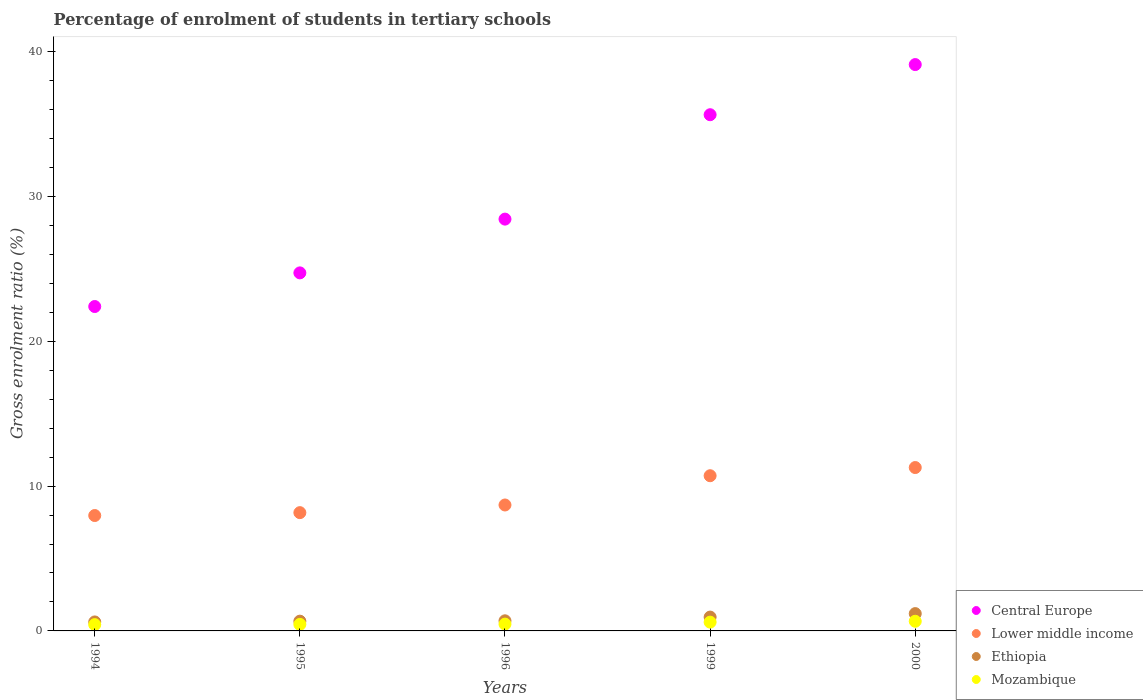What is the percentage of students enrolled in tertiary schools in Lower middle income in 1994?
Ensure brevity in your answer.  7.97. Across all years, what is the maximum percentage of students enrolled in tertiary schools in Lower middle income?
Give a very brief answer. 11.28. Across all years, what is the minimum percentage of students enrolled in tertiary schools in Lower middle income?
Provide a short and direct response. 7.97. In which year was the percentage of students enrolled in tertiary schools in Lower middle income maximum?
Make the answer very short. 2000. In which year was the percentage of students enrolled in tertiary schools in Ethiopia minimum?
Provide a succinct answer. 1994. What is the total percentage of students enrolled in tertiary schools in Mozambique in the graph?
Your answer should be compact. 2.63. What is the difference between the percentage of students enrolled in tertiary schools in Lower middle income in 1994 and that in 1995?
Provide a succinct answer. -0.2. What is the difference between the percentage of students enrolled in tertiary schools in Mozambique in 1994 and the percentage of students enrolled in tertiary schools in Lower middle income in 2000?
Your answer should be very brief. -10.84. What is the average percentage of students enrolled in tertiary schools in Mozambique per year?
Offer a terse response. 0.53. In the year 2000, what is the difference between the percentage of students enrolled in tertiary schools in Lower middle income and percentage of students enrolled in tertiary schools in Ethiopia?
Your answer should be very brief. 10.08. What is the ratio of the percentage of students enrolled in tertiary schools in Central Europe in 1995 to that in 1999?
Provide a short and direct response. 0.69. Is the difference between the percentage of students enrolled in tertiary schools in Lower middle income in 1995 and 2000 greater than the difference between the percentage of students enrolled in tertiary schools in Ethiopia in 1995 and 2000?
Keep it short and to the point. No. What is the difference between the highest and the second highest percentage of students enrolled in tertiary schools in Ethiopia?
Your response must be concise. 0.24. What is the difference between the highest and the lowest percentage of students enrolled in tertiary schools in Lower middle income?
Offer a terse response. 3.31. In how many years, is the percentage of students enrolled in tertiary schools in Mozambique greater than the average percentage of students enrolled in tertiary schools in Mozambique taken over all years?
Ensure brevity in your answer.  2. Is it the case that in every year, the sum of the percentage of students enrolled in tertiary schools in Ethiopia and percentage of students enrolled in tertiary schools in Mozambique  is greater than the percentage of students enrolled in tertiary schools in Lower middle income?
Your answer should be very brief. No. Does the percentage of students enrolled in tertiary schools in Mozambique monotonically increase over the years?
Provide a succinct answer. Yes. How many years are there in the graph?
Keep it short and to the point. 5. Are the values on the major ticks of Y-axis written in scientific E-notation?
Offer a very short reply. No. How many legend labels are there?
Your response must be concise. 4. How are the legend labels stacked?
Give a very brief answer. Vertical. What is the title of the graph?
Your answer should be compact. Percentage of enrolment of students in tertiary schools. Does "Hungary" appear as one of the legend labels in the graph?
Your answer should be very brief. No. What is the label or title of the Y-axis?
Give a very brief answer. Gross enrolment ratio (%). What is the Gross enrolment ratio (%) of Central Europe in 1994?
Provide a succinct answer. 22.4. What is the Gross enrolment ratio (%) of Lower middle income in 1994?
Keep it short and to the point. 7.97. What is the Gross enrolment ratio (%) in Ethiopia in 1994?
Your answer should be compact. 0.62. What is the Gross enrolment ratio (%) of Mozambique in 1994?
Your answer should be compact. 0.43. What is the Gross enrolment ratio (%) of Central Europe in 1995?
Keep it short and to the point. 24.72. What is the Gross enrolment ratio (%) in Lower middle income in 1995?
Provide a short and direct response. 8.17. What is the Gross enrolment ratio (%) in Ethiopia in 1995?
Make the answer very short. 0.67. What is the Gross enrolment ratio (%) in Mozambique in 1995?
Your answer should be very brief. 0.45. What is the Gross enrolment ratio (%) in Central Europe in 1996?
Keep it short and to the point. 28.43. What is the Gross enrolment ratio (%) in Lower middle income in 1996?
Provide a short and direct response. 8.69. What is the Gross enrolment ratio (%) of Ethiopia in 1996?
Make the answer very short. 0.7. What is the Gross enrolment ratio (%) in Mozambique in 1996?
Provide a succinct answer. 0.47. What is the Gross enrolment ratio (%) of Central Europe in 1999?
Offer a terse response. 35.64. What is the Gross enrolment ratio (%) in Lower middle income in 1999?
Keep it short and to the point. 10.71. What is the Gross enrolment ratio (%) of Ethiopia in 1999?
Offer a very short reply. 0.96. What is the Gross enrolment ratio (%) of Mozambique in 1999?
Your response must be concise. 0.61. What is the Gross enrolment ratio (%) of Central Europe in 2000?
Offer a terse response. 39.1. What is the Gross enrolment ratio (%) of Lower middle income in 2000?
Give a very brief answer. 11.28. What is the Gross enrolment ratio (%) in Ethiopia in 2000?
Offer a terse response. 1.19. What is the Gross enrolment ratio (%) of Mozambique in 2000?
Make the answer very short. 0.67. Across all years, what is the maximum Gross enrolment ratio (%) in Central Europe?
Your answer should be compact. 39.1. Across all years, what is the maximum Gross enrolment ratio (%) of Lower middle income?
Provide a succinct answer. 11.28. Across all years, what is the maximum Gross enrolment ratio (%) in Ethiopia?
Your answer should be very brief. 1.19. Across all years, what is the maximum Gross enrolment ratio (%) of Mozambique?
Give a very brief answer. 0.67. Across all years, what is the minimum Gross enrolment ratio (%) of Central Europe?
Ensure brevity in your answer.  22.4. Across all years, what is the minimum Gross enrolment ratio (%) of Lower middle income?
Keep it short and to the point. 7.97. Across all years, what is the minimum Gross enrolment ratio (%) in Ethiopia?
Your response must be concise. 0.62. Across all years, what is the minimum Gross enrolment ratio (%) in Mozambique?
Offer a terse response. 0.43. What is the total Gross enrolment ratio (%) in Central Europe in the graph?
Offer a terse response. 150.28. What is the total Gross enrolment ratio (%) of Lower middle income in the graph?
Your answer should be very brief. 46.82. What is the total Gross enrolment ratio (%) of Ethiopia in the graph?
Ensure brevity in your answer.  4.14. What is the total Gross enrolment ratio (%) in Mozambique in the graph?
Make the answer very short. 2.63. What is the difference between the Gross enrolment ratio (%) in Central Europe in 1994 and that in 1995?
Offer a terse response. -2.32. What is the difference between the Gross enrolment ratio (%) of Lower middle income in 1994 and that in 1995?
Provide a short and direct response. -0.2. What is the difference between the Gross enrolment ratio (%) in Ethiopia in 1994 and that in 1995?
Your answer should be very brief. -0.05. What is the difference between the Gross enrolment ratio (%) in Mozambique in 1994 and that in 1995?
Offer a terse response. -0.02. What is the difference between the Gross enrolment ratio (%) in Central Europe in 1994 and that in 1996?
Your answer should be compact. -6.03. What is the difference between the Gross enrolment ratio (%) of Lower middle income in 1994 and that in 1996?
Make the answer very short. -0.73. What is the difference between the Gross enrolment ratio (%) of Ethiopia in 1994 and that in 1996?
Your answer should be very brief. -0.08. What is the difference between the Gross enrolment ratio (%) in Mozambique in 1994 and that in 1996?
Offer a very short reply. -0.04. What is the difference between the Gross enrolment ratio (%) of Central Europe in 1994 and that in 1999?
Ensure brevity in your answer.  -13.24. What is the difference between the Gross enrolment ratio (%) of Lower middle income in 1994 and that in 1999?
Offer a very short reply. -2.75. What is the difference between the Gross enrolment ratio (%) of Ethiopia in 1994 and that in 1999?
Offer a terse response. -0.33. What is the difference between the Gross enrolment ratio (%) of Mozambique in 1994 and that in 1999?
Ensure brevity in your answer.  -0.17. What is the difference between the Gross enrolment ratio (%) in Central Europe in 1994 and that in 2000?
Make the answer very short. -16.7. What is the difference between the Gross enrolment ratio (%) in Lower middle income in 1994 and that in 2000?
Your answer should be compact. -3.31. What is the difference between the Gross enrolment ratio (%) in Ethiopia in 1994 and that in 2000?
Offer a very short reply. -0.57. What is the difference between the Gross enrolment ratio (%) of Mozambique in 1994 and that in 2000?
Your response must be concise. -0.23. What is the difference between the Gross enrolment ratio (%) of Central Europe in 1995 and that in 1996?
Ensure brevity in your answer.  -3.71. What is the difference between the Gross enrolment ratio (%) of Lower middle income in 1995 and that in 1996?
Offer a terse response. -0.53. What is the difference between the Gross enrolment ratio (%) of Ethiopia in 1995 and that in 1996?
Offer a very short reply. -0.02. What is the difference between the Gross enrolment ratio (%) in Mozambique in 1995 and that in 1996?
Offer a terse response. -0.02. What is the difference between the Gross enrolment ratio (%) in Central Europe in 1995 and that in 1999?
Offer a terse response. -10.92. What is the difference between the Gross enrolment ratio (%) of Lower middle income in 1995 and that in 1999?
Make the answer very short. -2.55. What is the difference between the Gross enrolment ratio (%) in Ethiopia in 1995 and that in 1999?
Your answer should be very brief. -0.28. What is the difference between the Gross enrolment ratio (%) in Mozambique in 1995 and that in 1999?
Give a very brief answer. -0.16. What is the difference between the Gross enrolment ratio (%) in Central Europe in 1995 and that in 2000?
Your answer should be very brief. -14.38. What is the difference between the Gross enrolment ratio (%) of Lower middle income in 1995 and that in 2000?
Offer a very short reply. -3.11. What is the difference between the Gross enrolment ratio (%) of Ethiopia in 1995 and that in 2000?
Make the answer very short. -0.52. What is the difference between the Gross enrolment ratio (%) of Mozambique in 1995 and that in 2000?
Provide a succinct answer. -0.22. What is the difference between the Gross enrolment ratio (%) in Central Europe in 1996 and that in 1999?
Offer a terse response. -7.21. What is the difference between the Gross enrolment ratio (%) of Lower middle income in 1996 and that in 1999?
Give a very brief answer. -2.02. What is the difference between the Gross enrolment ratio (%) of Ethiopia in 1996 and that in 1999?
Offer a terse response. -0.26. What is the difference between the Gross enrolment ratio (%) in Mozambique in 1996 and that in 1999?
Your answer should be very brief. -0.14. What is the difference between the Gross enrolment ratio (%) of Central Europe in 1996 and that in 2000?
Make the answer very short. -10.67. What is the difference between the Gross enrolment ratio (%) in Lower middle income in 1996 and that in 2000?
Make the answer very short. -2.58. What is the difference between the Gross enrolment ratio (%) in Ethiopia in 1996 and that in 2000?
Your answer should be compact. -0.5. What is the difference between the Gross enrolment ratio (%) of Mozambique in 1996 and that in 2000?
Provide a short and direct response. -0.2. What is the difference between the Gross enrolment ratio (%) of Central Europe in 1999 and that in 2000?
Provide a succinct answer. -3.46. What is the difference between the Gross enrolment ratio (%) of Lower middle income in 1999 and that in 2000?
Keep it short and to the point. -0.56. What is the difference between the Gross enrolment ratio (%) of Ethiopia in 1999 and that in 2000?
Provide a short and direct response. -0.24. What is the difference between the Gross enrolment ratio (%) in Mozambique in 1999 and that in 2000?
Your response must be concise. -0.06. What is the difference between the Gross enrolment ratio (%) of Central Europe in 1994 and the Gross enrolment ratio (%) of Lower middle income in 1995?
Provide a succinct answer. 14.23. What is the difference between the Gross enrolment ratio (%) in Central Europe in 1994 and the Gross enrolment ratio (%) in Ethiopia in 1995?
Give a very brief answer. 21.72. What is the difference between the Gross enrolment ratio (%) in Central Europe in 1994 and the Gross enrolment ratio (%) in Mozambique in 1995?
Offer a very short reply. 21.94. What is the difference between the Gross enrolment ratio (%) in Lower middle income in 1994 and the Gross enrolment ratio (%) in Ethiopia in 1995?
Offer a terse response. 7.29. What is the difference between the Gross enrolment ratio (%) in Lower middle income in 1994 and the Gross enrolment ratio (%) in Mozambique in 1995?
Give a very brief answer. 7.52. What is the difference between the Gross enrolment ratio (%) in Ethiopia in 1994 and the Gross enrolment ratio (%) in Mozambique in 1995?
Make the answer very short. 0.17. What is the difference between the Gross enrolment ratio (%) in Central Europe in 1994 and the Gross enrolment ratio (%) in Lower middle income in 1996?
Provide a short and direct response. 13.7. What is the difference between the Gross enrolment ratio (%) of Central Europe in 1994 and the Gross enrolment ratio (%) of Ethiopia in 1996?
Make the answer very short. 21.7. What is the difference between the Gross enrolment ratio (%) of Central Europe in 1994 and the Gross enrolment ratio (%) of Mozambique in 1996?
Provide a short and direct response. 21.93. What is the difference between the Gross enrolment ratio (%) of Lower middle income in 1994 and the Gross enrolment ratio (%) of Ethiopia in 1996?
Offer a very short reply. 7.27. What is the difference between the Gross enrolment ratio (%) of Lower middle income in 1994 and the Gross enrolment ratio (%) of Mozambique in 1996?
Your answer should be very brief. 7.5. What is the difference between the Gross enrolment ratio (%) of Ethiopia in 1994 and the Gross enrolment ratio (%) of Mozambique in 1996?
Offer a terse response. 0.15. What is the difference between the Gross enrolment ratio (%) in Central Europe in 1994 and the Gross enrolment ratio (%) in Lower middle income in 1999?
Offer a terse response. 11.68. What is the difference between the Gross enrolment ratio (%) in Central Europe in 1994 and the Gross enrolment ratio (%) in Ethiopia in 1999?
Your response must be concise. 21.44. What is the difference between the Gross enrolment ratio (%) in Central Europe in 1994 and the Gross enrolment ratio (%) in Mozambique in 1999?
Your answer should be compact. 21.79. What is the difference between the Gross enrolment ratio (%) of Lower middle income in 1994 and the Gross enrolment ratio (%) of Ethiopia in 1999?
Provide a succinct answer. 7.01. What is the difference between the Gross enrolment ratio (%) of Lower middle income in 1994 and the Gross enrolment ratio (%) of Mozambique in 1999?
Your answer should be very brief. 7.36. What is the difference between the Gross enrolment ratio (%) in Ethiopia in 1994 and the Gross enrolment ratio (%) in Mozambique in 1999?
Provide a succinct answer. 0.01. What is the difference between the Gross enrolment ratio (%) of Central Europe in 1994 and the Gross enrolment ratio (%) of Lower middle income in 2000?
Offer a very short reply. 11.12. What is the difference between the Gross enrolment ratio (%) in Central Europe in 1994 and the Gross enrolment ratio (%) in Ethiopia in 2000?
Your answer should be very brief. 21.2. What is the difference between the Gross enrolment ratio (%) in Central Europe in 1994 and the Gross enrolment ratio (%) in Mozambique in 2000?
Make the answer very short. 21.73. What is the difference between the Gross enrolment ratio (%) in Lower middle income in 1994 and the Gross enrolment ratio (%) in Ethiopia in 2000?
Your answer should be very brief. 6.77. What is the difference between the Gross enrolment ratio (%) in Lower middle income in 1994 and the Gross enrolment ratio (%) in Mozambique in 2000?
Offer a very short reply. 7.3. What is the difference between the Gross enrolment ratio (%) of Ethiopia in 1994 and the Gross enrolment ratio (%) of Mozambique in 2000?
Keep it short and to the point. -0.05. What is the difference between the Gross enrolment ratio (%) in Central Europe in 1995 and the Gross enrolment ratio (%) in Lower middle income in 1996?
Offer a terse response. 16.02. What is the difference between the Gross enrolment ratio (%) in Central Europe in 1995 and the Gross enrolment ratio (%) in Ethiopia in 1996?
Ensure brevity in your answer.  24.02. What is the difference between the Gross enrolment ratio (%) in Central Europe in 1995 and the Gross enrolment ratio (%) in Mozambique in 1996?
Your answer should be compact. 24.25. What is the difference between the Gross enrolment ratio (%) in Lower middle income in 1995 and the Gross enrolment ratio (%) in Ethiopia in 1996?
Offer a very short reply. 7.47. What is the difference between the Gross enrolment ratio (%) of Lower middle income in 1995 and the Gross enrolment ratio (%) of Mozambique in 1996?
Your answer should be compact. 7.7. What is the difference between the Gross enrolment ratio (%) in Ethiopia in 1995 and the Gross enrolment ratio (%) in Mozambique in 1996?
Your response must be concise. 0.2. What is the difference between the Gross enrolment ratio (%) in Central Europe in 1995 and the Gross enrolment ratio (%) in Lower middle income in 1999?
Give a very brief answer. 14. What is the difference between the Gross enrolment ratio (%) in Central Europe in 1995 and the Gross enrolment ratio (%) in Ethiopia in 1999?
Your response must be concise. 23.76. What is the difference between the Gross enrolment ratio (%) of Central Europe in 1995 and the Gross enrolment ratio (%) of Mozambique in 1999?
Keep it short and to the point. 24.11. What is the difference between the Gross enrolment ratio (%) of Lower middle income in 1995 and the Gross enrolment ratio (%) of Ethiopia in 1999?
Make the answer very short. 7.21. What is the difference between the Gross enrolment ratio (%) of Lower middle income in 1995 and the Gross enrolment ratio (%) of Mozambique in 1999?
Your answer should be compact. 7.56. What is the difference between the Gross enrolment ratio (%) in Ethiopia in 1995 and the Gross enrolment ratio (%) in Mozambique in 1999?
Provide a short and direct response. 0.07. What is the difference between the Gross enrolment ratio (%) in Central Europe in 1995 and the Gross enrolment ratio (%) in Lower middle income in 2000?
Provide a short and direct response. 13.44. What is the difference between the Gross enrolment ratio (%) in Central Europe in 1995 and the Gross enrolment ratio (%) in Ethiopia in 2000?
Make the answer very short. 23.52. What is the difference between the Gross enrolment ratio (%) in Central Europe in 1995 and the Gross enrolment ratio (%) in Mozambique in 2000?
Offer a terse response. 24.05. What is the difference between the Gross enrolment ratio (%) of Lower middle income in 1995 and the Gross enrolment ratio (%) of Ethiopia in 2000?
Your answer should be very brief. 6.97. What is the difference between the Gross enrolment ratio (%) of Lower middle income in 1995 and the Gross enrolment ratio (%) of Mozambique in 2000?
Offer a terse response. 7.5. What is the difference between the Gross enrolment ratio (%) of Ethiopia in 1995 and the Gross enrolment ratio (%) of Mozambique in 2000?
Ensure brevity in your answer.  0.01. What is the difference between the Gross enrolment ratio (%) in Central Europe in 1996 and the Gross enrolment ratio (%) in Lower middle income in 1999?
Offer a terse response. 17.72. What is the difference between the Gross enrolment ratio (%) of Central Europe in 1996 and the Gross enrolment ratio (%) of Ethiopia in 1999?
Your response must be concise. 27.48. What is the difference between the Gross enrolment ratio (%) in Central Europe in 1996 and the Gross enrolment ratio (%) in Mozambique in 1999?
Ensure brevity in your answer.  27.82. What is the difference between the Gross enrolment ratio (%) in Lower middle income in 1996 and the Gross enrolment ratio (%) in Ethiopia in 1999?
Provide a short and direct response. 7.74. What is the difference between the Gross enrolment ratio (%) of Lower middle income in 1996 and the Gross enrolment ratio (%) of Mozambique in 1999?
Offer a very short reply. 8.09. What is the difference between the Gross enrolment ratio (%) in Ethiopia in 1996 and the Gross enrolment ratio (%) in Mozambique in 1999?
Make the answer very short. 0.09. What is the difference between the Gross enrolment ratio (%) of Central Europe in 1996 and the Gross enrolment ratio (%) of Lower middle income in 2000?
Provide a succinct answer. 17.15. What is the difference between the Gross enrolment ratio (%) of Central Europe in 1996 and the Gross enrolment ratio (%) of Ethiopia in 2000?
Offer a terse response. 27.24. What is the difference between the Gross enrolment ratio (%) in Central Europe in 1996 and the Gross enrolment ratio (%) in Mozambique in 2000?
Offer a terse response. 27.76. What is the difference between the Gross enrolment ratio (%) of Lower middle income in 1996 and the Gross enrolment ratio (%) of Ethiopia in 2000?
Provide a succinct answer. 7.5. What is the difference between the Gross enrolment ratio (%) in Lower middle income in 1996 and the Gross enrolment ratio (%) in Mozambique in 2000?
Give a very brief answer. 8.03. What is the difference between the Gross enrolment ratio (%) in Ethiopia in 1996 and the Gross enrolment ratio (%) in Mozambique in 2000?
Your response must be concise. 0.03. What is the difference between the Gross enrolment ratio (%) of Central Europe in 1999 and the Gross enrolment ratio (%) of Lower middle income in 2000?
Give a very brief answer. 24.36. What is the difference between the Gross enrolment ratio (%) of Central Europe in 1999 and the Gross enrolment ratio (%) of Ethiopia in 2000?
Your answer should be compact. 34.44. What is the difference between the Gross enrolment ratio (%) of Central Europe in 1999 and the Gross enrolment ratio (%) of Mozambique in 2000?
Your answer should be very brief. 34.97. What is the difference between the Gross enrolment ratio (%) in Lower middle income in 1999 and the Gross enrolment ratio (%) in Ethiopia in 2000?
Offer a very short reply. 9.52. What is the difference between the Gross enrolment ratio (%) in Lower middle income in 1999 and the Gross enrolment ratio (%) in Mozambique in 2000?
Offer a very short reply. 10.05. What is the difference between the Gross enrolment ratio (%) of Ethiopia in 1999 and the Gross enrolment ratio (%) of Mozambique in 2000?
Keep it short and to the point. 0.29. What is the average Gross enrolment ratio (%) in Central Europe per year?
Offer a terse response. 30.06. What is the average Gross enrolment ratio (%) in Lower middle income per year?
Your answer should be very brief. 9.36. What is the average Gross enrolment ratio (%) in Ethiopia per year?
Your answer should be compact. 0.83. What is the average Gross enrolment ratio (%) in Mozambique per year?
Make the answer very short. 0.53. In the year 1994, what is the difference between the Gross enrolment ratio (%) of Central Europe and Gross enrolment ratio (%) of Lower middle income?
Offer a terse response. 14.43. In the year 1994, what is the difference between the Gross enrolment ratio (%) in Central Europe and Gross enrolment ratio (%) in Ethiopia?
Ensure brevity in your answer.  21.78. In the year 1994, what is the difference between the Gross enrolment ratio (%) of Central Europe and Gross enrolment ratio (%) of Mozambique?
Offer a very short reply. 21.96. In the year 1994, what is the difference between the Gross enrolment ratio (%) in Lower middle income and Gross enrolment ratio (%) in Ethiopia?
Make the answer very short. 7.35. In the year 1994, what is the difference between the Gross enrolment ratio (%) in Lower middle income and Gross enrolment ratio (%) in Mozambique?
Offer a terse response. 7.53. In the year 1994, what is the difference between the Gross enrolment ratio (%) in Ethiopia and Gross enrolment ratio (%) in Mozambique?
Ensure brevity in your answer.  0.19. In the year 1995, what is the difference between the Gross enrolment ratio (%) in Central Europe and Gross enrolment ratio (%) in Lower middle income?
Your answer should be compact. 16.55. In the year 1995, what is the difference between the Gross enrolment ratio (%) in Central Europe and Gross enrolment ratio (%) in Ethiopia?
Ensure brevity in your answer.  24.05. In the year 1995, what is the difference between the Gross enrolment ratio (%) of Central Europe and Gross enrolment ratio (%) of Mozambique?
Make the answer very short. 24.27. In the year 1995, what is the difference between the Gross enrolment ratio (%) in Lower middle income and Gross enrolment ratio (%) in Ethiopia?
Give a very brief answer. 7.49. In the year 1995, what is the difference between the Gross enrolment ratio (%) of Lower middle income and Gross enrolment ratio (%) of Mozambique?
Ensure brevity in your answer.  7.71. In the year 1995, what is the difference between the Gross enrolment ratio (%) in Ethiopia and Gross enrolment ratio (%) in Mozambique?
Make the answer very short. 0.22. In the year 1996, what is the difference between the Gross enrolment ratio (%) of Central Europe and Gross enrolment ratio (%) of Lower middle income?
Your answer should be compact. 19.74. In the year 1996, what is the difference between the Gross enrolment ratio (%) in Central Europe and Gross enrolment ratio (%) in Ethiopia?
Offer a very short reply. 27.73. In the year 1996, what is the difference between the Gross enrolment ratio (%) in Central Europe and Gross enrolment ratio (%) in Mozambique?
Give a very brief answer. 27.96. In the year 1996, what is the difference between the Gross enrolment ratio (%) in Lower middle income and Gross enrolment ratio (%) in Ethiopia?
Keep it short and to the point. 8. In the year 1996, what is the difference between the Gross enrolment ratio (%) in Lower middle income and Gross enrolment ratio (%) in Mozambique?
Ensure brevity in your answer.  8.22. In the year 1996, what is the difference between the Gross enrolment ratio (%) in Ethiopia and Gross enrolment ratio (%) in Mozambique?
Offer a terse response. 0.23. In the year 1999, what is the difference between the Gross enrolment ratio (%) in Central Europe and Gross enrolment ratio (%) in Lower middle income?
Give a very brief answer. 24.92. In the year 1999, what is the difference between the Gross enrolment ratio (%) in Central Europe and Gross enrolment ratio (%) in Ethiopia?
Provide a succinct answer. 34.68. In the year 1999, what is the difference between the Gross enrolment ratio (%) of Central Europe and Gross enrolment ratio (%) of Mozambique?
Provide a succinct answer. 35.03. In the year 1999, what is the difference between the Gross enrolment ratio (%) in Lower middle income and Gross enrolment ratio (%) in Ethiopia?
Your response must be concise. 9.76. In the year 1999, what is the difference between the Gross enrolment ratio (%) in Lower middle income and Gross enrolment ratio (%) in Mozambique?
Keep it short and to the point. 10.11. In the year 1999, what is the difference between the Gross enrolment ratio (%) of Ethiopia and Gross enrolment ratio (%) of Mozambique?
Give a very brief answer. 0.35. In the year 2000, what is the difference between the Gross enrolment ratio (%) in Central Europe and Gross enrolment ratio (%) in Lower middle income?
Your answer should be very brief. 27.82. In the year 2000, what is the difference between the Gross enrolment ratio (%) in Central Europe and Gross enrolment ratio (%) in Ethiopia?
Ensure brevity in your answer.  37.9. In the year 2000, what is the difference between the Gross enrolment ratio (%) in Central Europe and Gross enrolment ratio (%) in Mozambique?
Provide a short and direct response. 38.43. In the year 2000, what is the difference between the Gross enrolment ratio (%) of Lower middle income and Gross enrolment ratio (%) of Ethiopia?
Ensure brevity in your answer.  10.08. In the year 2000, what is the difference between the Gross enrolment ratio (%) of Lower middle income and Gross enrolment ratio (%) of Mozambique?
Your response must be concise. 10.61. In the year 2000, what is the difference between the Gross enrolment ratio (%) of Ethiopia and Gross enrolment ratio (%) of Mozambique?
Ensure brevity in your answer.  0.53. What is the ratio of the Gross enrolment ratio (%) in Central Europe in 1994 to that in 1995?
Give a very brief answer. 0.91. What is the ratio of the Gross enrolment ratio (%) of Lower middle income in 1994 to that in 1995?
Offer a terse response. 0.98. What is the ratio of the Gross enrolment ratio (%) in Ethiopia in 1994 to that in 1995?
Give a very brief answer. 0.92. What is the ratio of the Gross enrolment ratio (%) of Mozambique in 1994 to that in 1995?
Give a very brief answer. 0.96. What is the ratio of the Gross enrolment ratio (%) in Central Europe in 1994 to that in 1996?
Give a very brief answer. 0.79. What is the ratio of the Gross enrolment ratio (%) of Lower middle income in 1994 to that in 1996?
Offer a very short reply. 0.92. What is the ratio of the Gross enrolment ratio (%) of Ethiopia in 1994 to that in 1996?
Provide a succinct answer. 0.89. What is the ratio of the Gross enrolment ratio (%) in Mozambique in 1994 to that in 1996?
Your answer should be compact. 0.92. What is the ratio of the Gross enrolment ratio (%) in Central Europe in 1994 to that in 1999?
Keep it short and to the point. 0.63. What is the ratio of the Gross enrolment ratio (%) in Lower middle income in 1994 to that in 1999?
Offer a terse response. 0.74. What is the ratio of the Gross enrolment ratio (%) of Ethiopia in 1994 to that in 1999?
Provide a succinct answer. 0.65. What is the ratio of the Gross enrolment ratio (%) of Mozambique in 1994 to that in 1999?
Ensure brevity in your answer.  0.72. What is the ratio of the Gross enrolment ratio (%) of Central Europe in 1994 to that in 2000?
Your answer should be very brief. 0.57. What is the ratio of the Gross enrolment ratio (%) of Lower middle income in 1994 to that in 2000?
Offer a very short reply. 0.71. What is the ratio of the Gross enrolment ratio (%) of Ethiopia in 1994 to that in 2000?
Offer a very short reply. 0.52. What is the ratio of the Gross enrolment ratio (%) in Mozambique in 1994 to that in 2000?
Provide a succinct answer. 0.65. What is the ratio of the Gross enrolment ratio (%) in Central Europe in 1995 to that in 1996?
Provide a succinct answer. 0.87. What is the ratio of the Gross enrolment ratio (%) in Lower middle income in 1995 to that in 1996?
Give a very brief answer. 0.94. What is the ratio of the Gross enrolment ratio (%) of Ethiopia in 1995 to that in 1996?
Ensure brevity in your answer.  0.96. What is the ratio of the Gross enrolment ratio (%) of Mozambique in 1995 to that in 1996?
Keep it short and to the point. 0.96. What is the ratio of the Gross enrolment ratio (%) of Central Europe in 1995 to that in 1999?
Your answer should be very brief. 0.69. What is the ratio of the Gross enrolment ratio (%) in Lower middle income in 1995 to that in 1999?
Provide a short and direct response. 0.76. What is the ratio of the Gross enrolment ratio (%) of Ethiopia in 1995 to that in 1999?
Provide a short and direct response. 0.7. What is the ratio of the Gross enrolment ratio (%) in Mozambique in 1995 to that in 1999?
Your answer should be very brief. 0.74. What is the ratio of the Gross enrolment ratio (%) in Central Europe in 1995 to that in 2000?
Offer a terse response. 0.63. What is the ratio of the Gross enrolment ratio (%) in Lower middle income in 1995 to that in 2000?
Your response must be concise. 0.72. What is the ratio of the Gross enrolment ratio (%) in Ethiopia in 1995 to that in 2000?
Give a very brief answer. 0.56. What is the ratio of the Gross enrolment ratio (%) in Mozambique in 1995 to that in 2000?
Ensure brevity in your answer.  0.68. What is the ratio of the Gross enrolment ratio (%) in Central Europe in 1996 to that in 1999?
Make the answer very short. 0.8. What is the ratio of the Gross enrolment ratio (%) in Lower middle income in 1996 to that in 1999?
Your answer should be very brief. 0.81. What is the ratio of the Gross enrolment ratio (%) in Ethiopia in 1996 to that in 1999?
Provide a short and direct response. 0.73. What is the ratio of the Gross enrolment ratio (%) in Mozambique in 1996 to that in 1999?
Provide a short and direct response. 0.78. What is the ratio of the Gross enrolment ratio (%) in Central Europe in 1996 to that in 2000?
Keep it short and to the point. 0.73. What is the ratio of the Gross enrolment ratio (%) in Lower middle income in 1996 to that in 2000?
Provide a succinct answer. 0.77. What is the ratio of the Gross enrolment ratio (%) in Ethiopia in 1996 to that in 2000?
Your response must be concise. 0.58. What is the ratio of the Gross enrolment ratio (%) in Mozambique in 1996 to that in 2000?
Provide a short and direct response. 0.71. What is the ratio of the Gross enrolment ratio (%) in Central Europe in 1999 to that in 2000?
Your response must be concise. 0.91. What is the ratio of the Gross enrolment ratio (%) in Lower middle income in 1999 to that in 2000?
Keep it short and to the point. 0.95. What is the ratio of the Gross enrolment ratio (%) in Ethiopia in 1999 to that in 2000?
Offer a very short reply. 0.8. What is the ratio of the Gross enrolment ratio (%) of Mozambique in 1999 to that in 2000?
Offer a very short reply. 0.91. What is the difference between the highest and the second highest Gross enrolment ratio (%) of Central Europe?
Ensure brevity in your answer.  3.46. What is the difference between the highest and the second highest Gross enrolment ratio (%) of Lower middle income?
Your response must be concise. 0.56. What is the difference between the highest and the second highest Gross enrolment ratio (%) of Ethiopia?
Keep it short and to the point. 0.24. What is the difference between the highest and the second highest Gross enrolment ratio (%) of Mozambique?
Provide a succinct answer. 0.06. What is the difference between the highest and the lowest Gross enrolment ratio (%) of Central Europe?
Offer a terse response. 16.7. What is the difference between the highest and the lowest Gross enrolment ratio (%) in Lower middle income?
Ensure brevity in your answer.  3.31. What is the difference between the highest and the lowest Gross enrolment ratio (%) of Ethiopia?
Your response must be concise. 0.57. What is the difference between the highest and the lowest Gross enrolment ratio (%) in Mozambique?
Give a very brief answer. 0.23. 